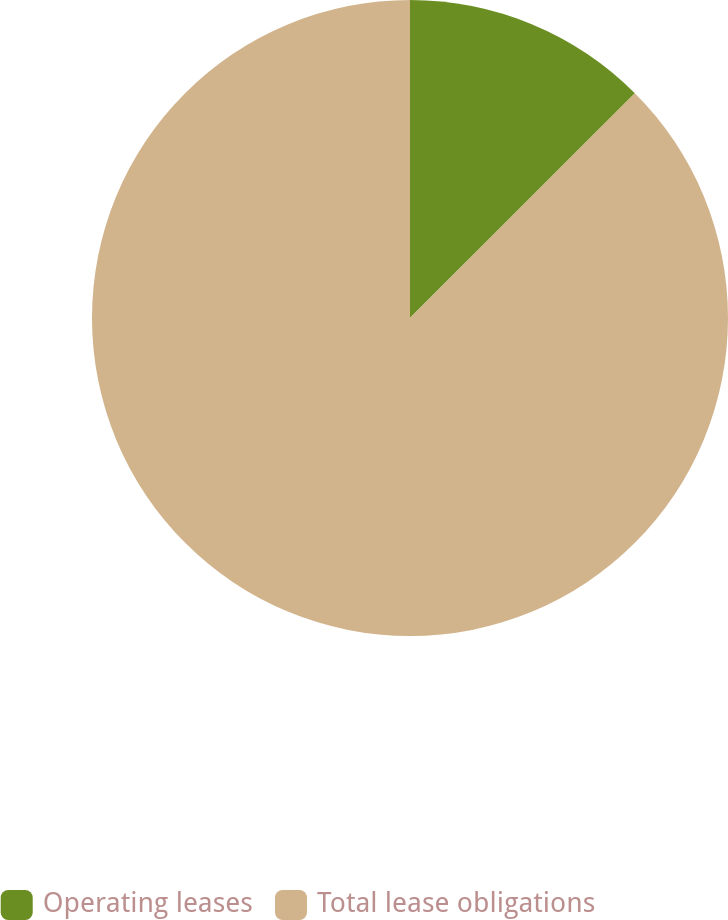Convert chart to OTSL. <chart><loc_0><loc_0><loc_500><loc_500><pie_chart><fcel>Operating leases<fcel>Total lease obligations<nl><fcel>12.5%<fcel>87.5%<nl></chart> 